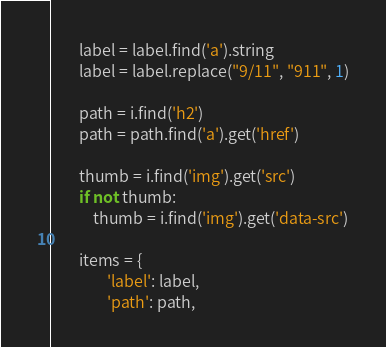<code> <loc_0><loc_0><loc_500><loc_500><_Python_>		label = label.find('a').string
		label = label.replace("9/11", "911", 1)

		path = i.find('h2')
		path = path.find('a').get('href')
		
		thumb = i.find('img').get('src')
		if not thumb:
			thumb = i.find('img').get('data-src')

		items = {
				'label': label,
				'path': path,</code> 